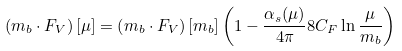Convert formula to latex. <formula><loc_0><loc_0><loc_500><loc_500>\left ( m _ { b } \cdot F _ { V } \right ) [ \mu ] = \left ( m _ { b } \cdot F _ { V } \right ) [ m _ { b } ] \left ( 1 - \frac { \alpha _ { s } ( \mu ) } { 4 \pi } 8 C _ { F } \ln \frac { \mu } { m _ { b } } \right )</formula> 